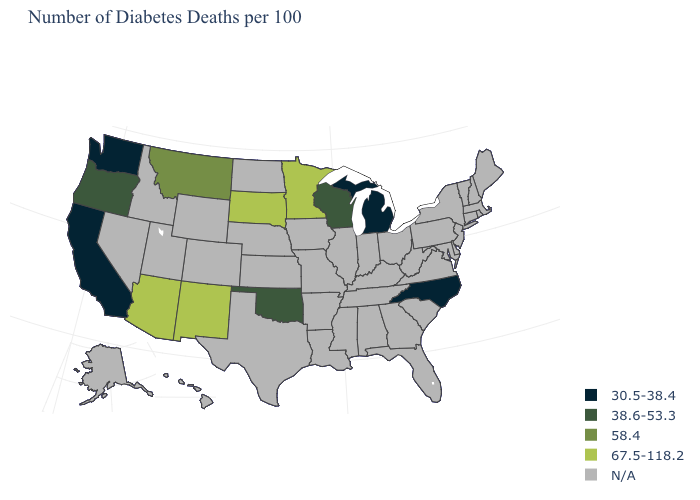Name the states that have a value in the range N/A?
Short answer required. Alabama, Alaska, Arkansas, Colorado, Connecticut, Delaware, Florida, Georgia, Hawaii, Idaho, Illinois, Indiana, Iowa, Kansas, Kentucky, Louisiana, Maine, Maryland, Massachusetts, Mississippi, Missouri, Nebraska, Nevada, New Hampshire, New Jersey, New York, North Dakota, Ohio, Pennsylvania, Rhode Island, South Carolina, Tennessee, Texas, Utah, Vermont, Virginia, West Virginia, Wyoming. What is the value of New York?
Answer briefly. N/A. Which states have the lowest value in the USA?
Concise answer only. California, Michigan, North Carolina, Washington. Name the states that have a value in the range 58.4?
Give a very brief answer. Montana. What is the value of West Virginia?
Concise answer only. N/A. Name the states that have a value in the range 58.4?
Write a very short answer. Montana. Does Oklahoma have the lowest value in the South?
Keep it brief. No. Name the states that have a value in the range N/A?
Write a very short answer. Alabama, Alaska, Arkansas, Colorado, Connecticut, Delaware, Florida, Georgia, Hawaii, Idaho, Illinois, Indiana, Iowa, Kansas, Kentucky, Louisiana, Maine, Maryland, Massachusetts, Mississippi, Missouri, Nebraska, Nevada, New Hampshire, New Jersey, New York, North Dakota, Ohio, Pennsylvania, Rhode Island, South Carolina, Tennessee, Texas, Utah, Vermont, Virginia, West Virginia, Wyoming. What is the lowest value in the USA?
Concise answer only. 30.5-38.4. What is the value of Vermont?
Be succinct. N/A. What is the lowest value in states that border South Carolina?
Be succinct. 30.5-38.4. Does Minnesota have the highest value in the MidWest?
Keep it brief. Yes. What is the value of Florida?
Be succinct. N/A. 